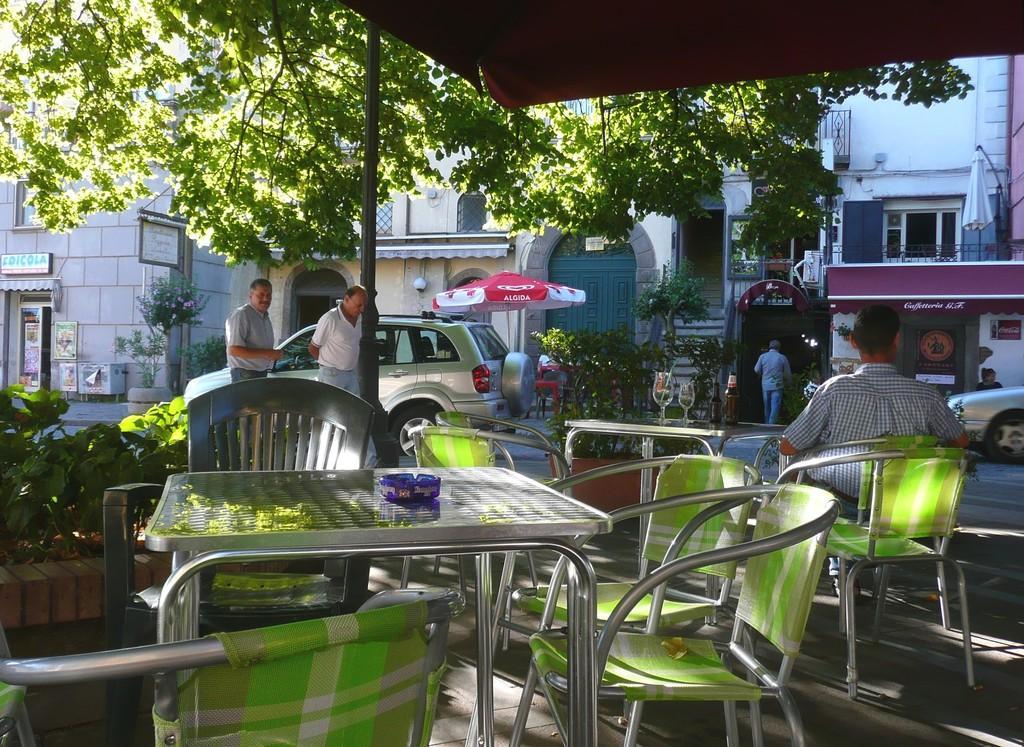How would you summarize this image in a sentence or two? In this image I can see number of chairs, few tables and two glasses. I can also see few people, vehicles. In the background I can see number of buildings and a tree. 